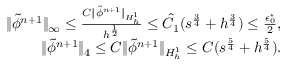<formula> <loc_0><loc_0><loc_500><loc_500>\begin{array} { r l r } & { \| \tilde { \phi } ^ { n + 1 } \| _ { \infty } \leq \frac { C \| \tilde { \phi } ^ { n + 1 } \| _ { H _ { h } ^ { 1 } } } { h ^ { \frac { 1 } { 2 } } } \leq \hat { C } _ { 1 } ( s ^ { \frac { 3 } { 4 } } + h ^ { \frac { 3 } { 4 } } ) \leq \frac { \epsilon _ { 0 } ^ { ^ { * } } } { 2 } , } \\ & { \| \tilde { \phi } ^ { n + 1 } \| _ { 4 } \leq C \| \tilde { \phi } ^ { n + 1 } \| _ { H _ { h } ^ { 1 } } \leq C ( s ^ { \frac { 5 } { 4 } } + h ^ { \frac { 5 } { 4 } } ) . } \end{array}</formula> 